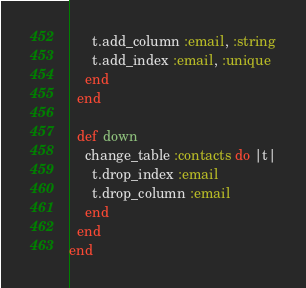Convert code to text. <code><loc_0><loc_0><loc_500><loc_500><_Crystal_>      t.add_column :email, :string
      t.add_index :email, :unique
    end
  end

  def down
    change_table :contacts do |t|
      t.drop_index :email
      t.drop_column :email
    end
  end
end
</code> 